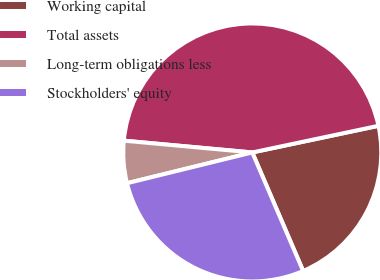Convert chart to OTSL. <chart><loc_0><loc_0><loc_500><loc_500><pie_chart><fcel>Working capital<fcel>Total assets<fcel>Long-term obligations less<fcel>Stockholders' equity<nl><fcel>21.86%<fcel>45.23%<fcel>5.29%<fcel>27.62%<nl></chart> 